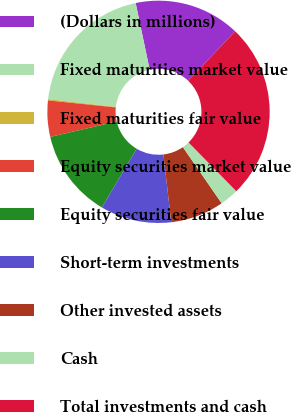<chart> <loc_0><loc_0><loc_500><loc_500><pie_chart><fcel>(Dollars in millions)<fcel>Fixed maturities market value<fcel>Fixed maturities fair value<fcel>Equity securities market value<fcel>Equity securities fair value<fcel>Short-term investments<fcel>Other invested assets<fcel>Cash<fcel>Total investments and cash<nl><fcel>15.41%<fcel>19.89%<fcel>0.18%<fcel>5.26%<fcel>12.87%<fcel>10.33%<fcel>7.79%<fcel>2.72%<fcel>25.55%<nl></chart> 